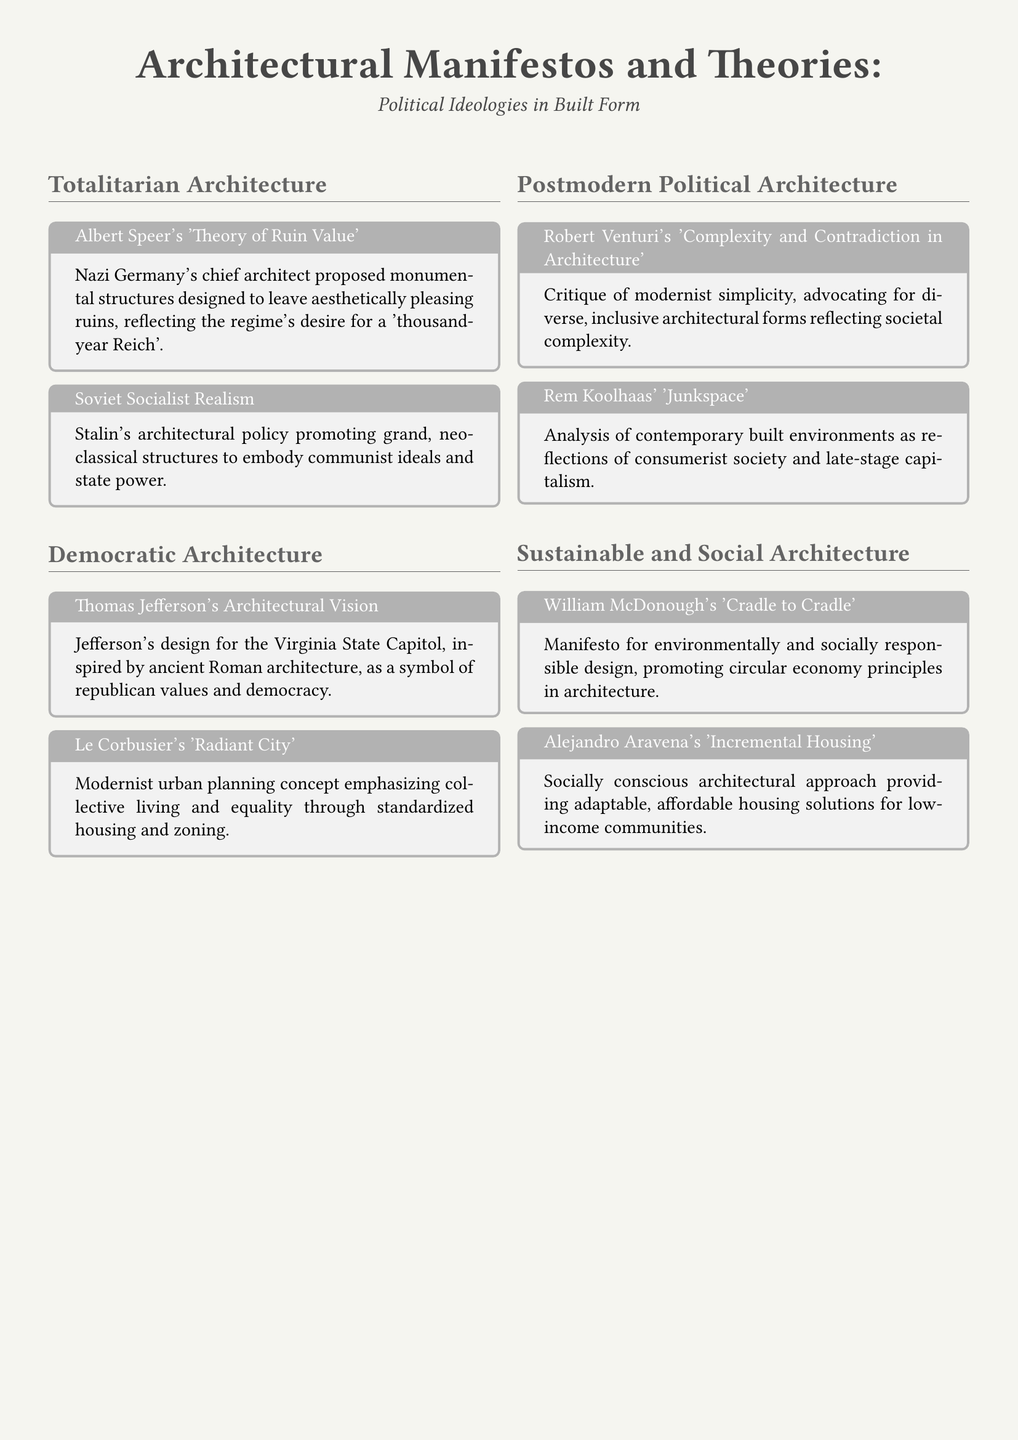What is the main theme of the document? The document focuses on the relationship between architecture and political ideologies, showcasing various manifestos and theories.
Answer: Political Ideologies in Built Form Who is associated with the 'Theory of Ruin Value'? The document mentions Albert Speer as the chief architect who proposed this theory during Nazi Germany.
Answer: Albert Speer Which architectural policy is aligned with Stalin? The document references Soviet Socialist Realism as the architectural policy promoted by Stalin to reflect communist ideals.
Answer: Soviet Socialist Realism What concept did Le Corbusier introduce? The document outlines Le Corbusier's 'Radiant City' as a modernist urban planning concept focusing on collective living.
Answer: Radiant City What does William McDonough advocate for in architecture? The document highlights McDonough's manifesto for environmentally and socially responsible design, emphasizing circular economy principles.
Answer: Cradle to Cradle Which architect critiqued modernist simplicity? Robert Venturi is mentioned in the document for his critique of modernist simplicity and advocacy for diverse architectural forms.
Answer: Robert Venturi What does Alejandro Aravena's approach address? The document states that Aravena's 'Incremental Housing' focuses on providing adaptable housing for low-income communities.
Answer: Incremental Housing How does Rem Koolhaas describe contemporary environments? The document presents Koolhaas' concept of 'Junkspace' as an analysis of built environments in relation to consumerist society.
Answer: Junkspace What is the architectural vision of Thomas Jefferson? Jefferson's design for the Virginia State Capitol is depicted in the document as a symbol of republican values and democracy.
Answer: Architectural Vision 